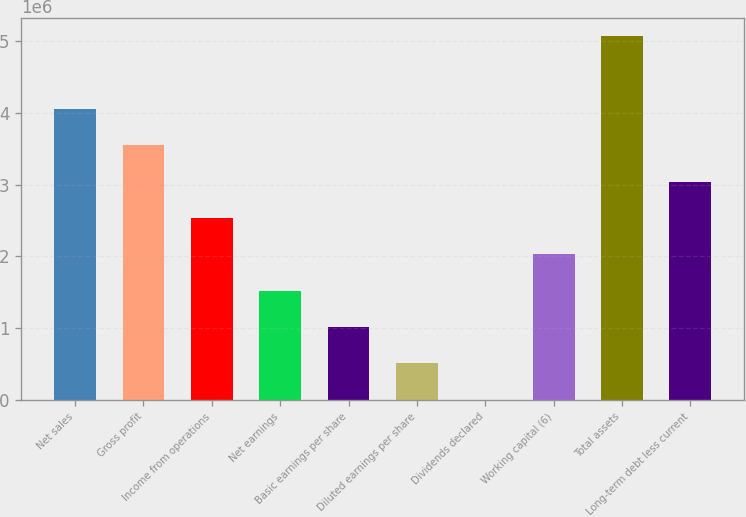<chart> <loc_0><loc_0><loc_500><loc_500><bar_chart><fcel>Net sales<fcel>Gross profit<fcel>Income from operations<fcel>Net earnings<fcel>Basic earnings per share<fcel>Diluted earnings per share<fcel>Dividends declared<fcel>Working capital (6)<fcel>Total assets<fcel>Long-term debt less current<nl><fcel>4.05562e+06<fcel>3.54867e+06<fcel>2.53476e+06<fcel>1.52086e+06<fcel>1.01391e+06<fcel>506953<fcel>0.4<fcel>2.02781e+06<fcel>5.06952e+06<fcel>3.04171e+06<nl></chart> 